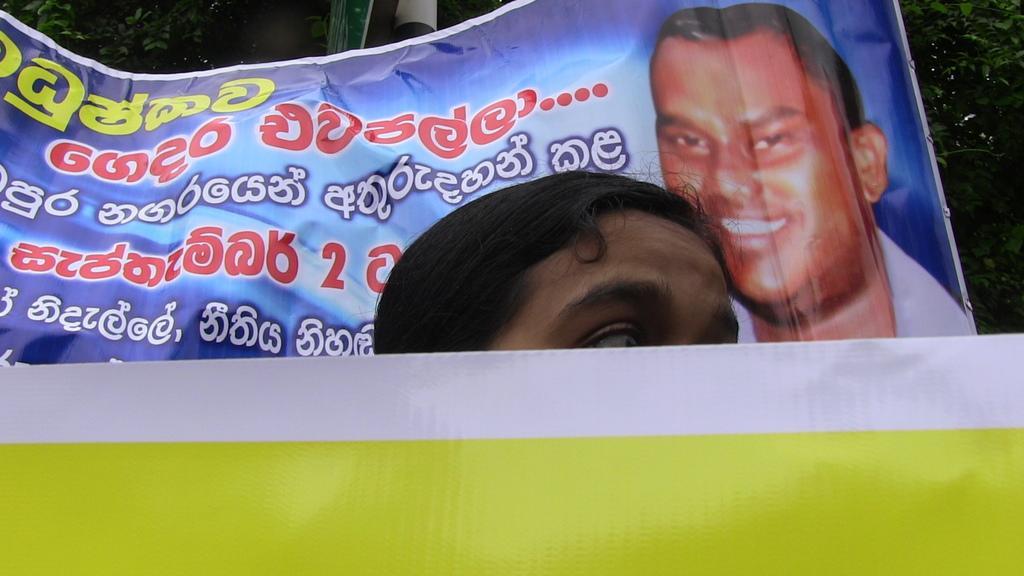Could you give a brief overview of what you see in this image? In the center of the image we can see a person head. At the bottom there is a banner. In the background we can see a flexi and trees. 